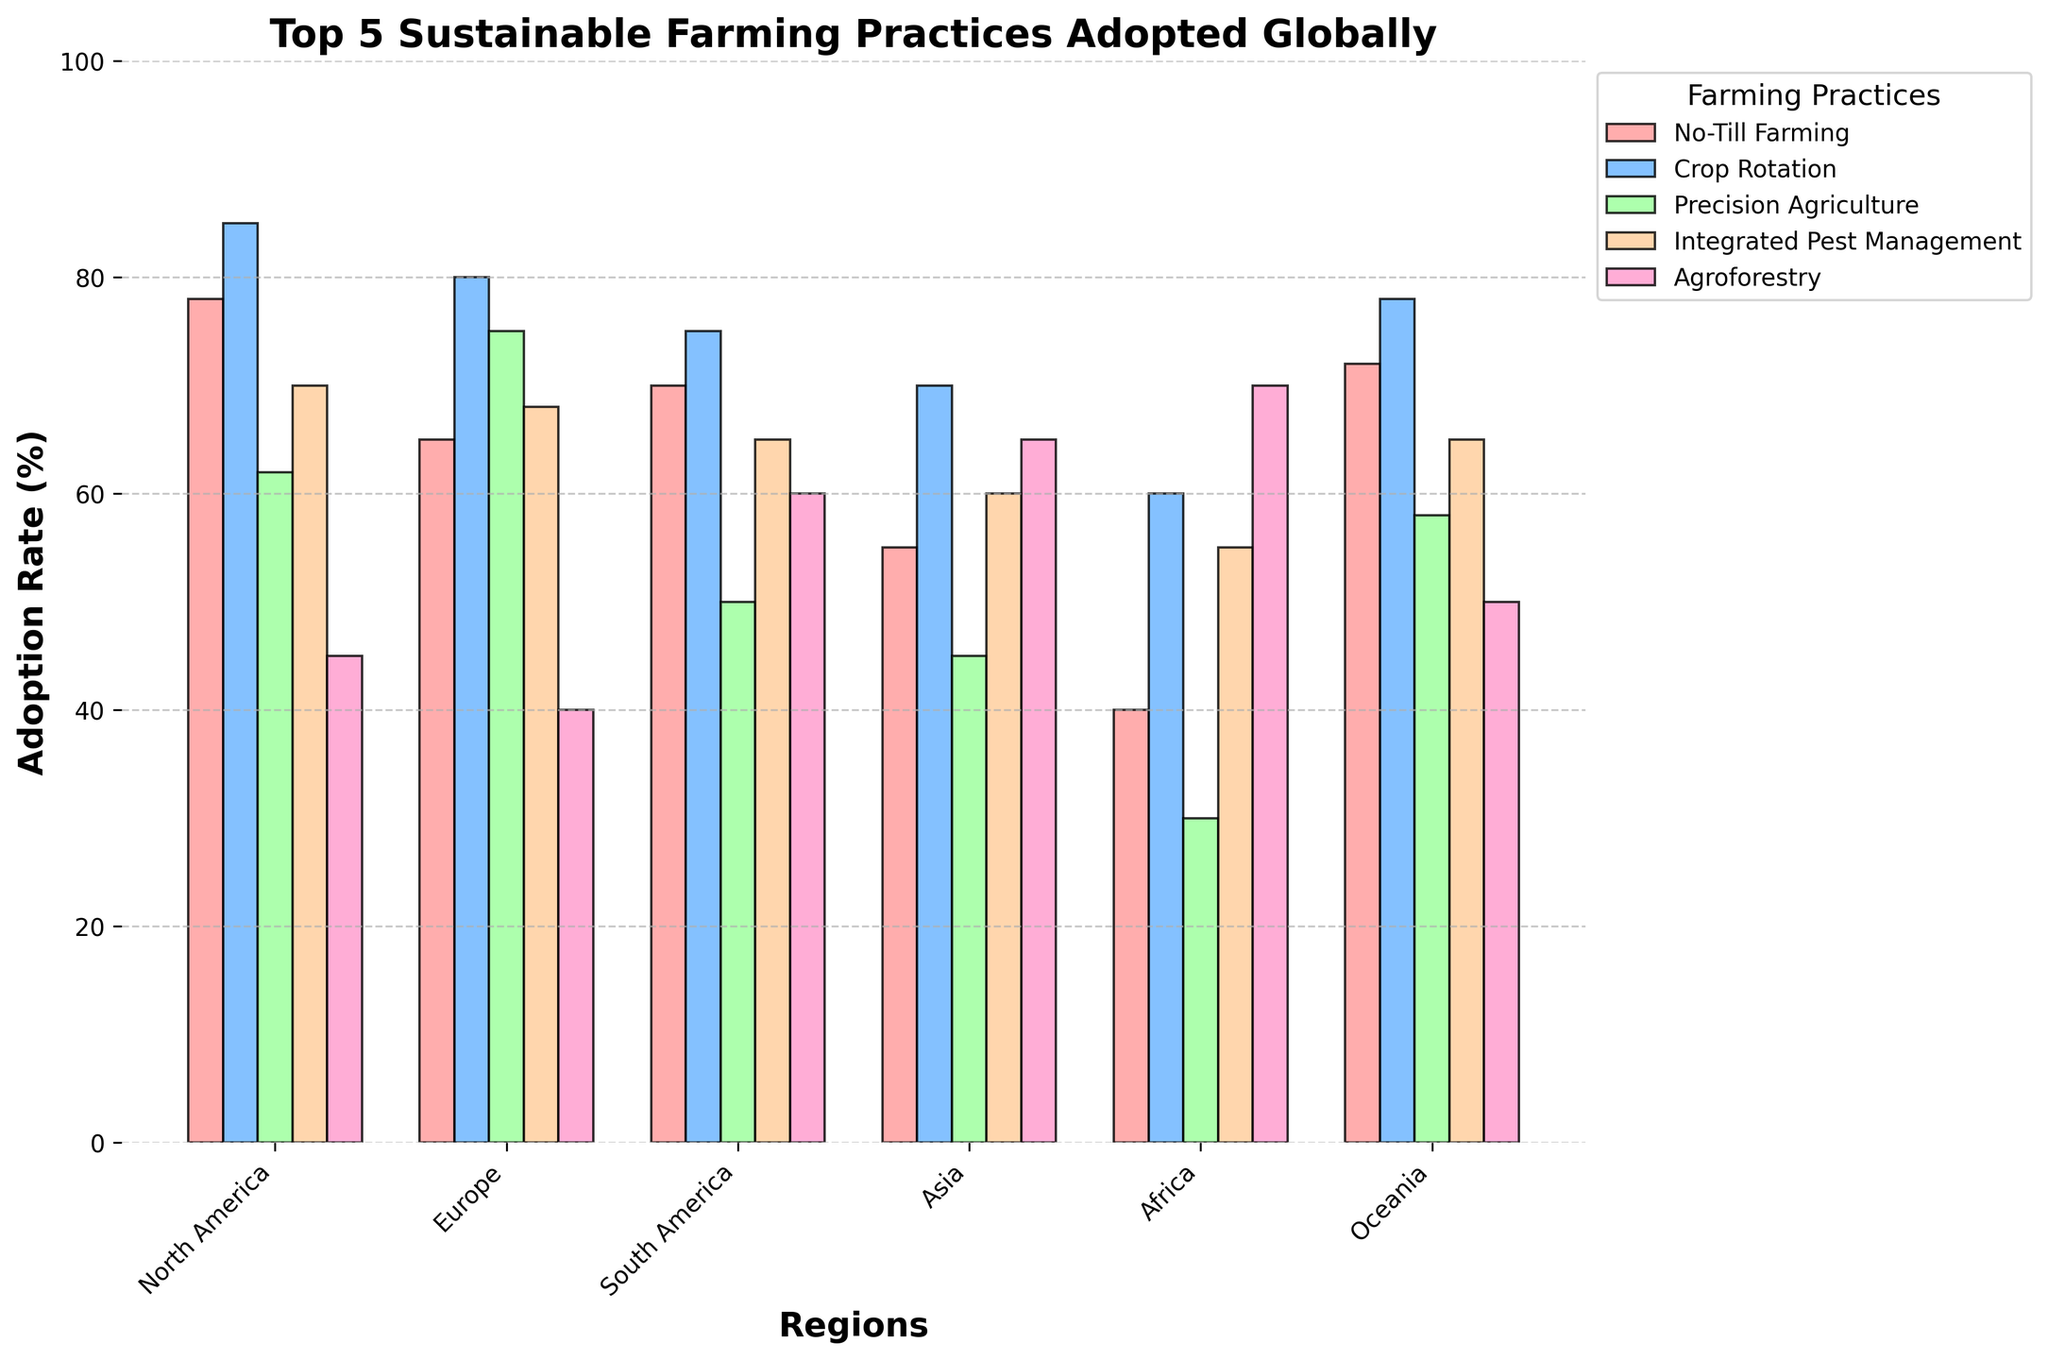Which region has the highest adoption rate for Agroforestry? Look at the Agroforestry bars and compare their heights across regions. The bar for Africa is the tallest.
Answer: Africa What is the difference in the adoption rates of No-Till Farming between North America and Africa? Locate the No-Till Farming bars for both regions. Subtract Africa’s adoption rate (40) from North America’s (78).
Answer: 38 Which two regions have the closest adoption rates for Integrated Pest Management? Compare the heights of the Integrated Pest Management bars. Oceania and South America both have rates of 65.
Answer: Oceania and South America What is the average adoption rate of Precision Agriculture across all regions? Sum the adoption rates of Precision Agriculture (62, 75, 50, 45, 30, 58) and divide by the number of regions (6). \((62+75+50+45+30+58) / 6 = 53.33\)
Answer: 53.33 Which sustainable farming practice is adopted more in Europe compared to Asia? Compare the bars for Europe and Asia across all practices. Europe has higher adoption rates in No-Till Farming (65 vs 55), Crop Rotation (80 vs 70), Precision Agriculture (75 vs 45), and Integrated Pest Management (68 vs 60).
Answer: No-Till Farming, Crop Rotation, Precision Agriculture, Integrated Pest Management Which practice shows the least variation in adoption rates across all regions? Look at the height differences of all bars within each practice. Integrated Pest Management appears to have the most consistent heights.
Answer: Integrated Pest Management What is the combined adoption rate of Crop Rotation and Agroforestry in South America? Sum the adoption rates of Crop Rotation and Agroforestry in South America (75 + 60).
Answer: 135 Between Africa and Oceania, which region has a higher average adoption rate across all practices? Calculate the average for both regions: Africa (40+60+30+55+70)/5 = 51, Oceania (72+78+58+65+50)/5 = 64.6. Oceania has a higher average.
Answer: Oceania Which farming practice has the highest adoption rate in Europe? Compare the heights of all the bars for Europe. Crop Rotation has the highest rate at 80.
Answer: Crop Rotation 